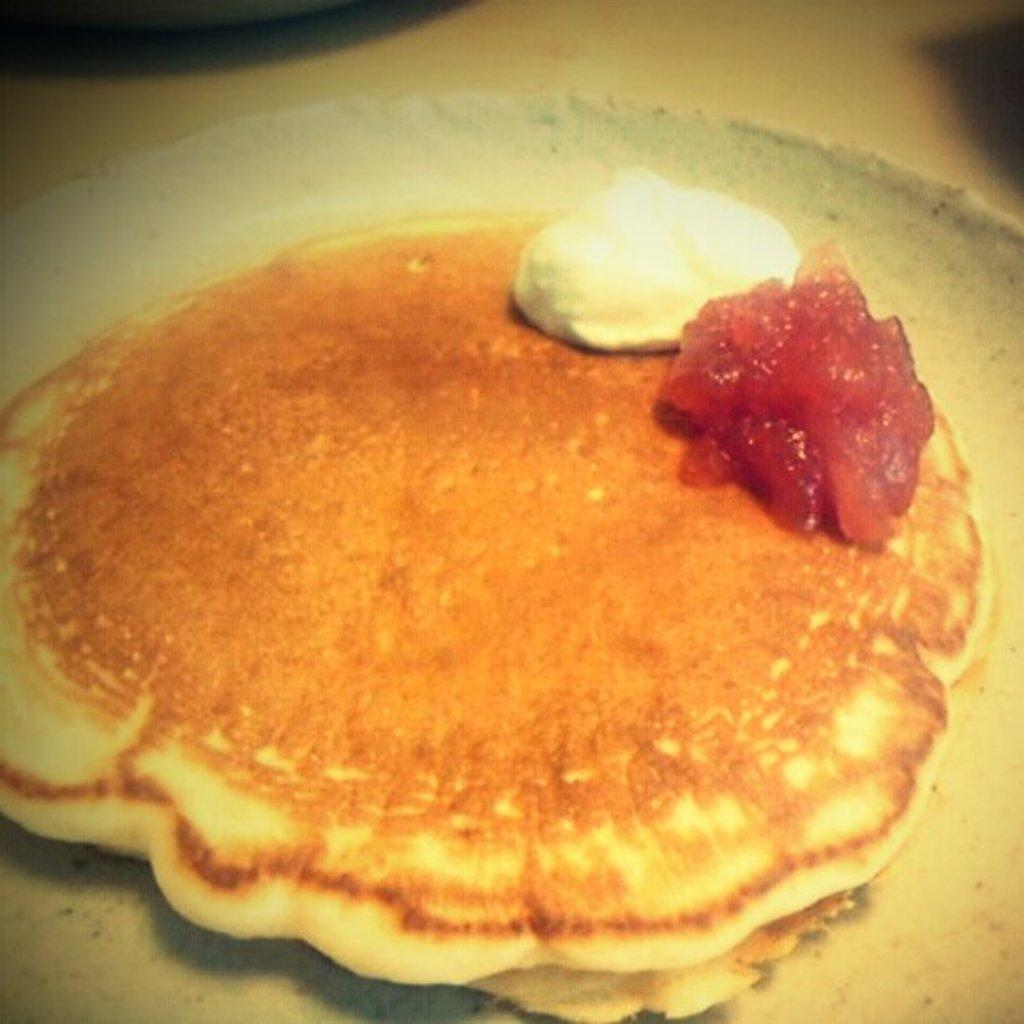What can be seen on the plate in the image? There is a food item on the plate in the image. Can you describe the plate in the image? The plate is visible in the image, but no specific details about its shape, color, or material are provided. What type of clouds can be seen in the image? There are no clouds visible in the image, as it only features a plate with a food item on it. 